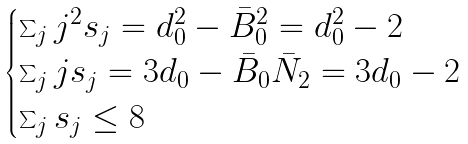<formula> <loc_0><loc_0><loc_500><loc_500>\begin{cases} \sum _ { j } j ^ { 2 } s _ { j } = d _ { 0 } ^ { 2 } - \bar { B } _ { 0 } ^ { 2 } = d _ { 0 } ^ { 2 } - 2 \\ \sum _ { j } j s _ { j } = 3 d _ { 0 } - \bar { B } _ { 0 } \bar { N } _ { 2 } = 3 d _ { 0 } - 2 \\ \sum _ { j } s _ { j } \leq 8 \end{cases}</formula> 